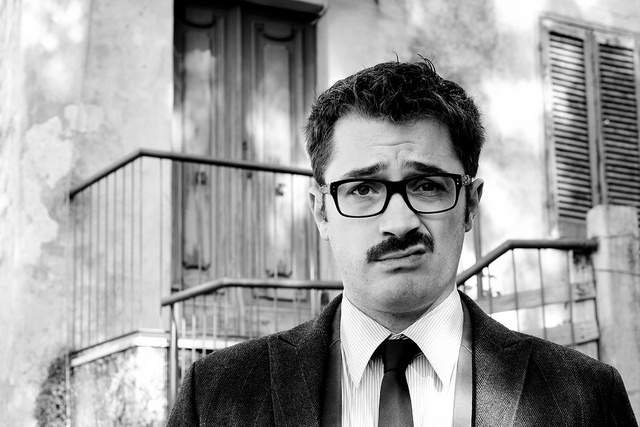Describe the objects in this image and their specific colors. I can see people in white, black, lightgray, darkgray, and gray tones and tie in white, black, gray, darkgray, and lightgray tones in this image. 